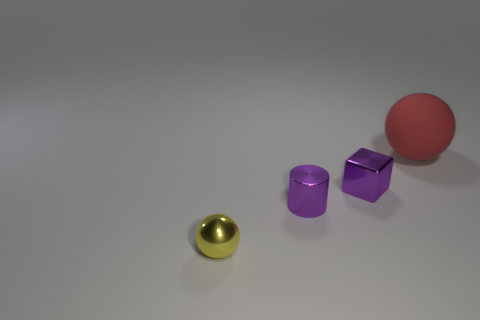What might be the purpose of these objects? These objects could serve educational purposes, possibly for a physics demonstration about geometry, light reflection and refraction, or materials' properties. They can also be used in design and art to study color and shape interactions. Are these objects real or digitally created? Based on their uniform color and perfect geometric shapes, coupled with the flawless background, it's likely that these objects are digitally rendered for a visualization or graphic design purpose. 